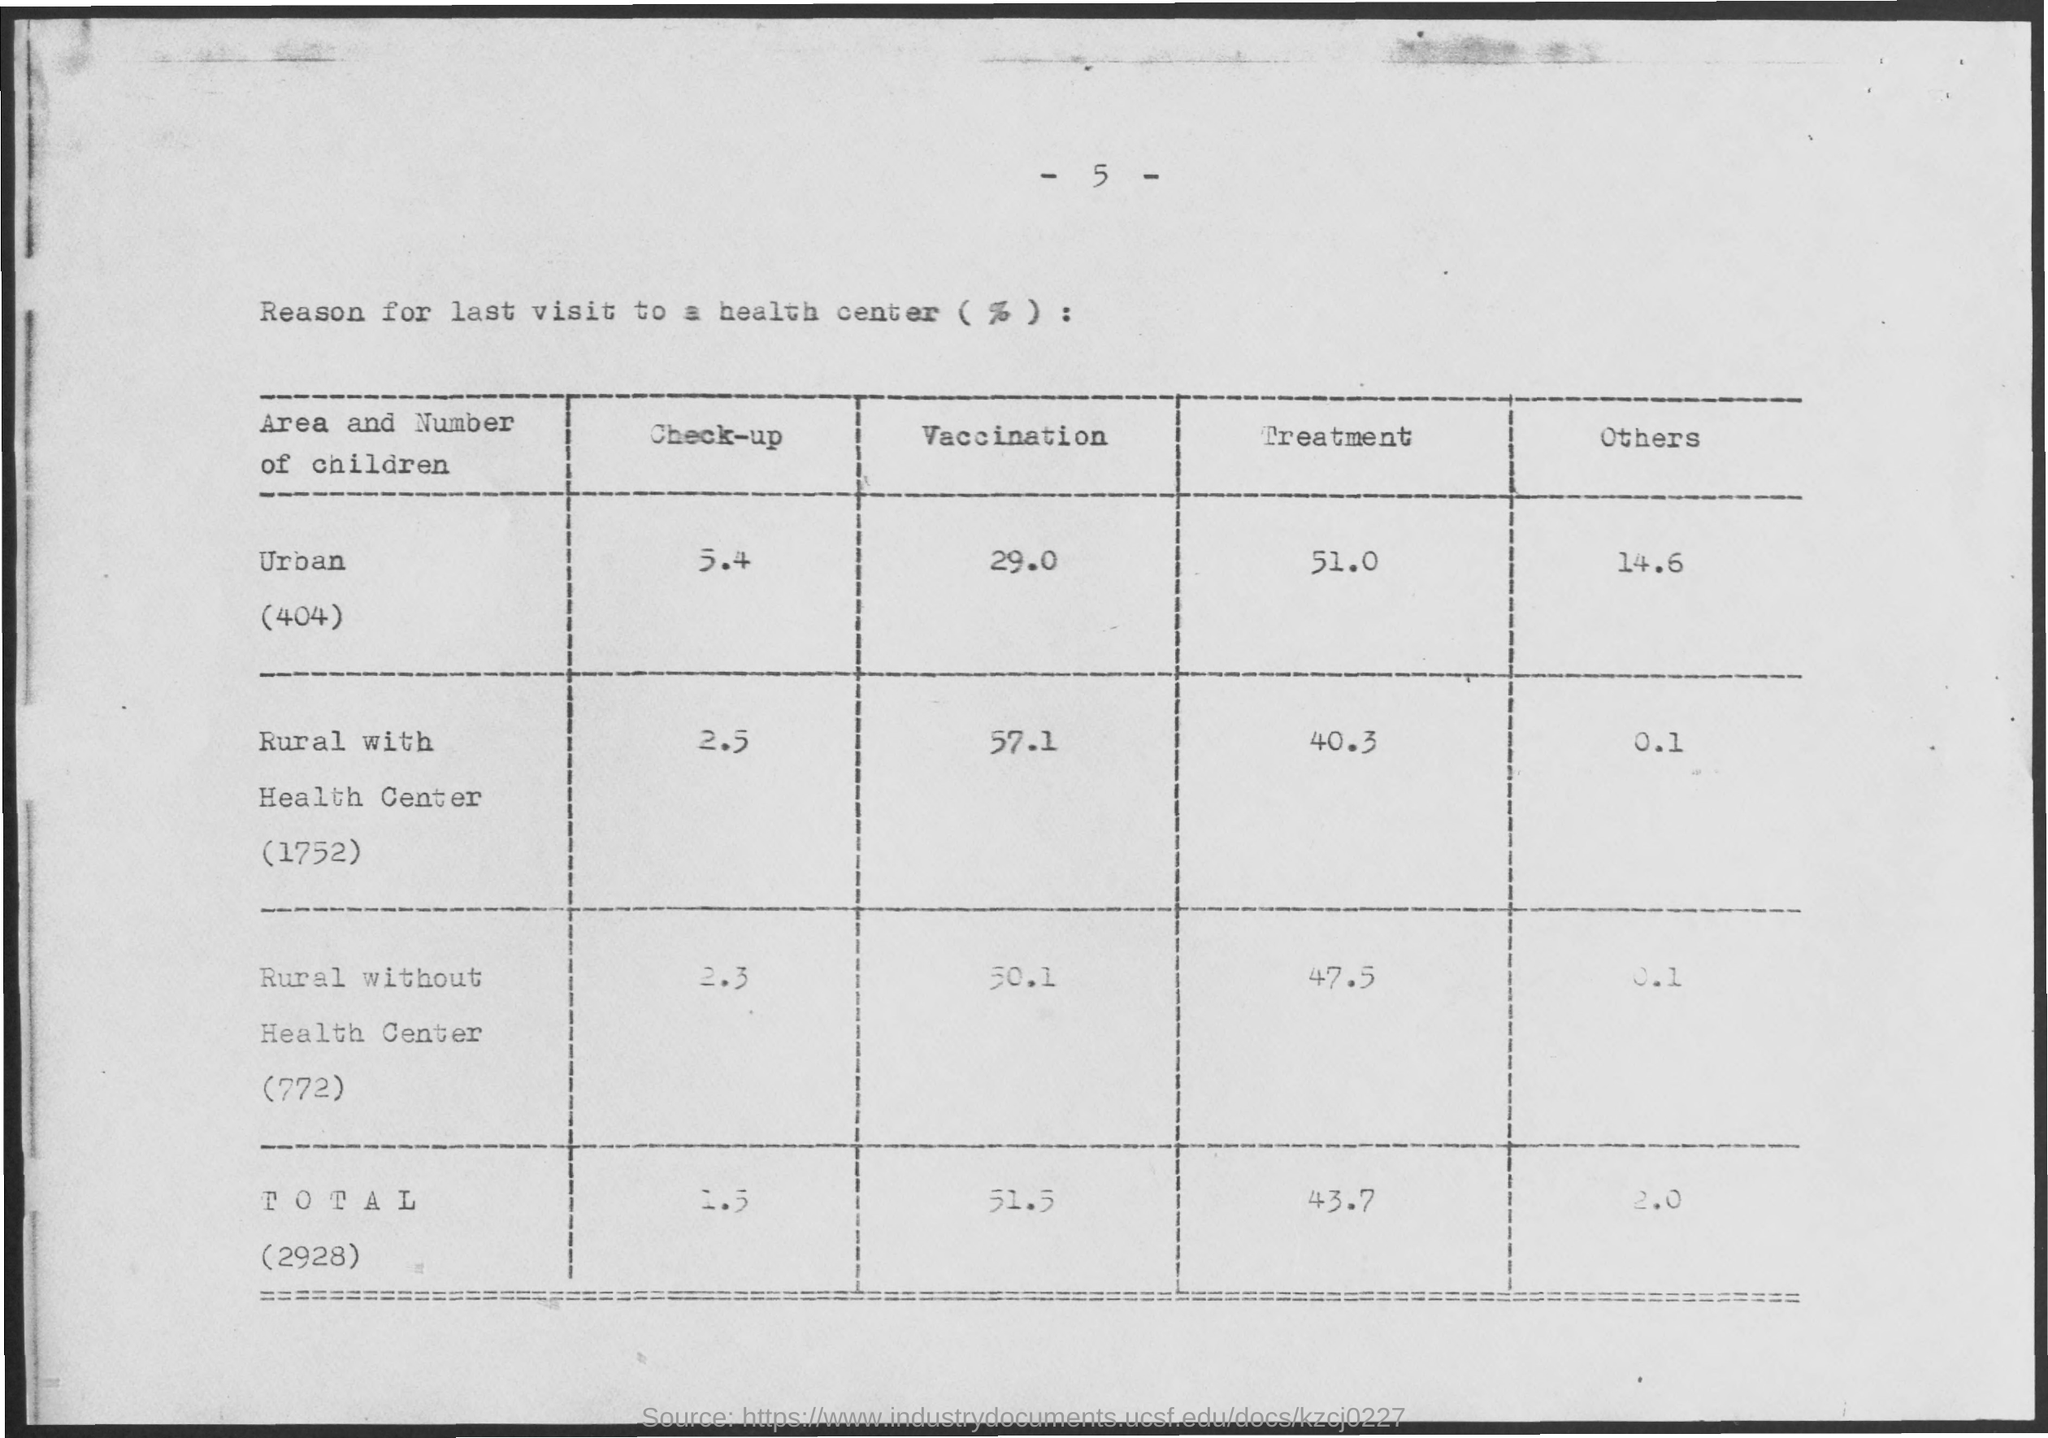What is the title of the table?
Make the answer very short. Reason for last visit to a health center (%) :. How many children were in the category Urban?
Give a very brief answer. 404. What percentage of children from Rural with Health Center went for vaccination?
Offer a very short reply. 57.1. What percentage of children from Urban area went for treatment?
Ensure brevity in your answer.  51.0. 